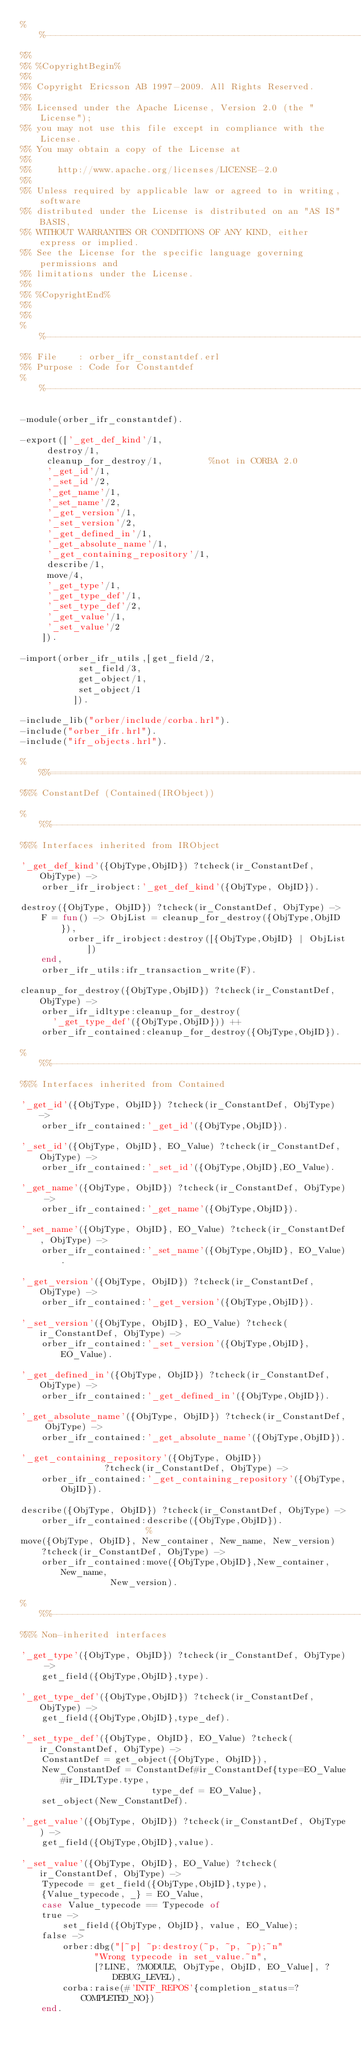Convert code to text. <code><loc_0><loc_0><loc_500><loc_500><_Erlang_>%%--------------------------------------------------------------------
%%
%% %CopyrightBegin%
%% 
%% Copyright Ericsson AB 1997-2009. All Rights Reserved.
%% 
%% Licensed under the Apache License, Version 2.0 (the "License");
%% you may not use this file except in compliance with the License.
%% You may obtain a copy of the License at
%%
%%     http://www.apache.org/licenses/LICENSE-2.0
%%
%% Unless required by applicable law or agreed to in writing, software
%% distributed under the License is distributed on an "AS IS" BASIS,
%% WITHOUT WARRANTIES OR CONDITIONS OF ANY KIND, either express or implied.
%% See the License for the specific language governing permissions and
%% limitations under the License.
%% 
%% %CopyrightEnd%
%%
%%
%%----------------------------------------------------------------------
%% File    : orber_ifr_constantdef.erl
%% Purpose : Code for Constantdef
%%----------------------------------------------------------------------

-module(orber_ifr_constantdef).

-export(['_get_def_kind'/1,
	 destroy/1,
	 cleanup_for_destroy/1,			%not in CORBA 2.0
	 '_get_id'/1,
	 '_set_id'/2,
	 '_get_name'/1,
	 '_set_name'/2,
	 '_get_version'/1,
	 '_set_version'/2,
	 '_get_defined_in'/1,
	 '_get_absolute_name'/1,
	 '_get_containing_repository'/1,
	 describe/1,
	 move/4,
	 '_get_type'/1,
	 '_get_type_def'/1,
	 '_set_type_def'/2,
	 '_get_value'/1,
	 '_set_value'/2
	]).

-import(orber_ifr_utils,[get_field/2,
		   set_field/3,
		   get_object/1,
		   set_object/1
		  ]).

-include_lib("orber/include/corba.hrl").
-include("orber_ifr.hrl").
-include("ifr_objects.hrl").

%%%======================================================================
%%% ConstantDef (Contained(IRObject))

%%%----------------------------------------------------------------------
%%% Interfaces inherited from IRObject

'_get_def_kind'({ObjType,ObjID}) ?tcheck(ir_ConstantDef,ObjType) ->
    orber_ifr_irobject:'_get_def_kind'({ObjType, ObjID}).

destroy({ObjType, ObjID}) ?tcheck(ir_ConstantDef, ObjType) ->
    F = fun() -> ObjList = cleanup_for_destroy({ObjType,ObjID}),
		 orber_ifr_irobject:destroy([{ObjType,ObjID} | ObjList])
	end,
    orber_ifr_utils:ifr_transaction_write(F).

cleanup_for_destroy({ObjType,ObjID}) ?tcheck(ir_ConstantDef, ObjType) ->
    orber_ifr_idltype:cleanup_for_destroy(
      '_get_type_def'({ObjType,ObjID})) ++
	orber_ifr_contained:cleanup_for_destroy({ObjType,ObjID}).

%%%----------------------------------------------------------------------
%%% Interfaces inherited from Contained

'_get_id'({ObjType, ObjID}) ?tcheck(ir_ConstantDef, ObjType) ->
    orber_ifr_contained:'_get_id'({ObjType,ObjID}).

'_set_id'({ObjType, ObjID}, EO_Value) ?tcheck(ir_ConstantDef, ObjType) ->
    orber_ifr_contained:'_set_id'({ObjType,ObjID},EO_Value).

'_get_name'({ObjType, ObjID}) ?tcheck(ir_ConstantDef, ObjType) ->
    orber_ifr_contained:'_get_name'({ObjType,ObjID}).

'_set_name'({ObjType, ObjID}, EO_Value) ?tcheck(ir_ConstantDef, ObjType) ->
    orber_ifr_contained:'_set_name'({ObjType,ObjID}, EO_Value).

'_get_version'({ObjType, ObjID}) ?tcheck(ir_ConstantDef,ObjType) ->
    orber_ifr_contained:'_get_version'({ObjType,ObjID}).

'_set_version'({ObjType, ObjID}, EO_Value) ?tcheck(ir_ConstantDef, ObjType) ->
    orber_ifr_contained:'_set_version'({ObjType,ObjID},EO_Value).

'_get_defined_in'({ObjType, ObjID}) ?tcheck(ir_ConstantDef, ObjType) ->
    orber_ifr_contained:'_get_defined_in'({ObjType,ObjID}).

'_get_absolute_name'({ObjType, ObjID}) ?tcheck(ir_ConstantDef, ObjType) ->
    orber_ifr_contained:'_get_absolute_name'({ObjType,ObjID}).

'_get_containing_repository'({ObjType, ObjID})
			    ?tcheck(ir_ConstantDef, ObjType) ->
    orber_ifr_contained:'_get_containing_repository'({ObjType,ObjID}).

describe({ObjType, ObjID}) ?tcheck(ir_ConstantDef, ObjType) ->
    orber_ifr_contained:describe({ObjType,ObjID}).
						%
move({ObjType, ObjID}, New_container, New_name, New_version)
    ?tcheck(ir_ConstantDef, ObjType) ->
    orber_ifr_contained:move({ObjType,ObjID},New_container,New_name,
			     New_version).

%%%----------------------------------------------------------------------
%%% Non-inherited interfaces

'_get_type'({ObjType, ObjID}) ?tcheck(ir_ConstantDef, ObjType) ->
    get_field({ObjType,ObjID},type).

'_get_type_def'({ObjType,ObjID}) ?tcheck(ir_ConstantDef,ObjType) ->
    get_field({ObjType,ObjID},type_def).

'_set_type_def'({ObjType, ObjID}, EO_Value) ?tcheck(ir_ConstantDef, ObjType) ->
    ConstantDef = get_object({ObjType, ObjID}),
    New_ConstantDef = ConstantDef#ir_ConstantDef{type=EO_Value#ir_IDLType.type,
						 type_def = EO_Value},
    set_object(New_ConstantDef).

'_get_value'({ObjType, ObjID}) ?tcheck(ir_ConstantDef, ObjType) ->
    get_field({ObjType,ObjID},value).

'_set_value'({ObjType, ObjID}, EO_Value) ?tcheck(ir_ConstantDef, ObjType) ->
    Typecode = get_field({ObjType,ObjID},type),
    {Value_typecode, _} = EO_Value,
    case Value_typecode == Typecode of
	true ->
	    set_field({ObjType, ObjID}, value, EO_Value);
	false ->
	    orber:dbg("[~p] ~p:destroy(~p, ~p, ~p);~n"
		      "Wrong typecode in set_value.~n", 
		      [?LINE, ?MODULE, ObjType, ObjID, EO_Value], ?DEBUG_LEVEL),
	    corba:raise(#'INTF_REPOS'{completion_status=?COMPLETED_NO})
    end.
</code> 